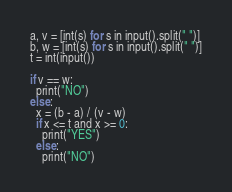<code> <loc_0><loc_0><loc_500><loc_500><_Python_>a, v = [int(s) for s in input().split(" ")]
b, w = [int(s) for s in input().split(" ")]
t = int(input())

if v == w:
  print("NO")
else:
  x = (b - a) / (v - w)
  if x <= t and x >= 0:
    print("YES")
  else:
    print("NO")</code> 